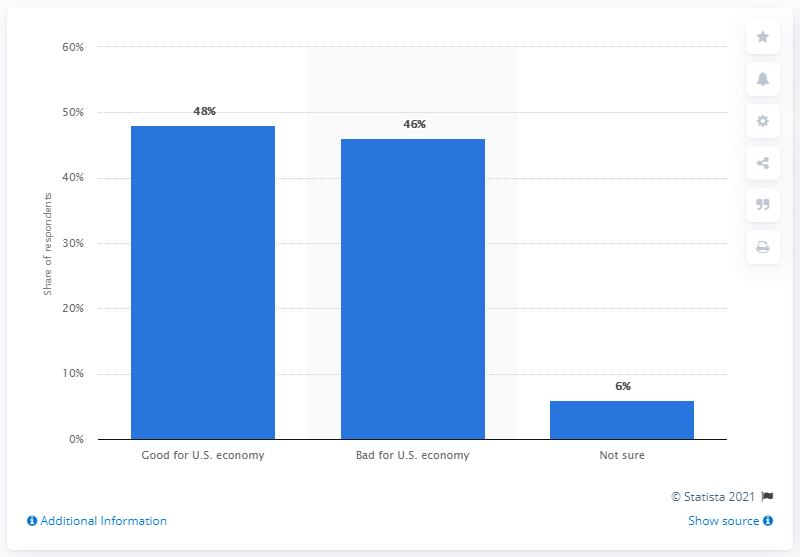Specify some key components in this picture. According to a survey, 52% of people either believe that NAFTA is bad for the US economy or are unsure about its impact. A significant percentage of people believe that NAFTA has been positive for the US economy. 